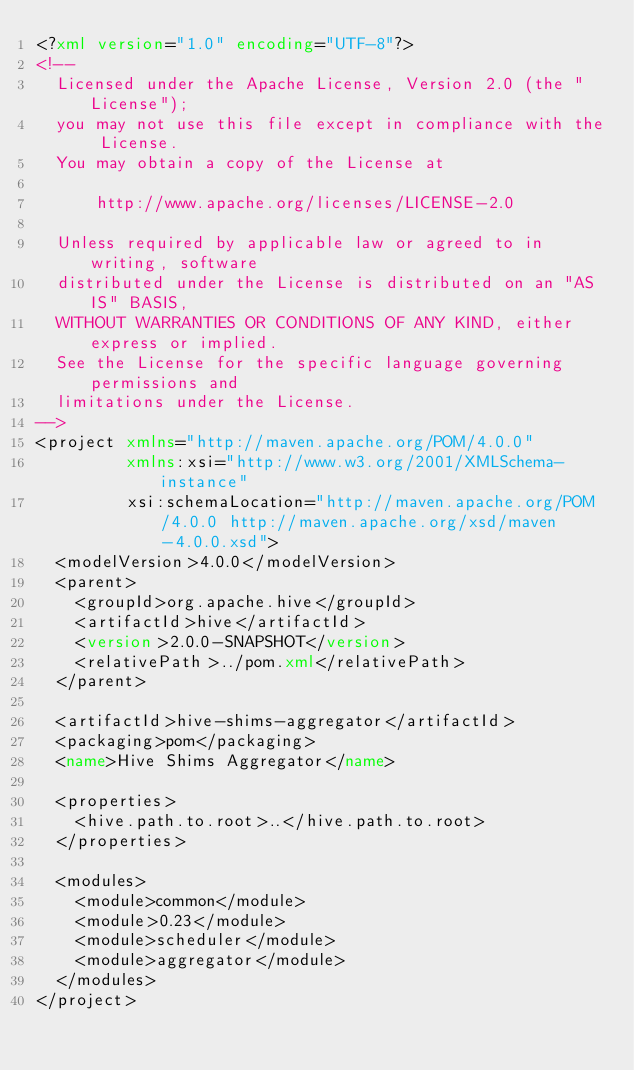<code> <loc_0><loc_0><loc_500><loc_500><_XML_><?xml version="1.0" encoding="UTF-8"?>
<!--
  Licensed under the Apache License, Version 2.0 (the "License");
  you may not use this file except in compliance with the License.
  You may obtain a copy of the License at

      http://www.apache.org/licenses/LICENSE-2.0

  Unless required by applicable law or agreed to in writing, software
  distributed under the License is distributed on an "AS IS" BASIS,
  WITHOUT WARRANTIES OR CONDITIONS OF ANY KIND, either express or implied.
  See the License for the specific language governing permissions and
  limitations under the License.
-->
<project xmlns="http://maven.apache.org/POM/4.0.0"
         xmlns:xsi="http://www.w3.org/2001/XMLSchema-instance"
         xsi:schemaLocation="http://maven.apache.org/POM/4.0.0 http://maven.apache.org/xsd/maven-4.0.0.xsd">
  <modelVersion>4.0.0</modelVersion>
  <parent>
    <groupId>org.apache.hive</groupId>
    <artifactId>hive</artifactId>
    <version>2.0.0-SNAPSHOT</version>
    <relativePath>../pom.xml</relativePath>
  </parent>

  <artifactId>hive-shims-aggregator</artifactId>
  <packaging>pom</packaging>
  <name>Hive Shims Aggregator</name>

  <properties>
    <hive.path.to.root>..</hive.path.to.root>
  </properties>

  <modules>
    <module>common</module>
    <module>0.23</module>
    <module>scheduler</module>
    <module>aggregator</module>
  </modules>
</project>
</code> 